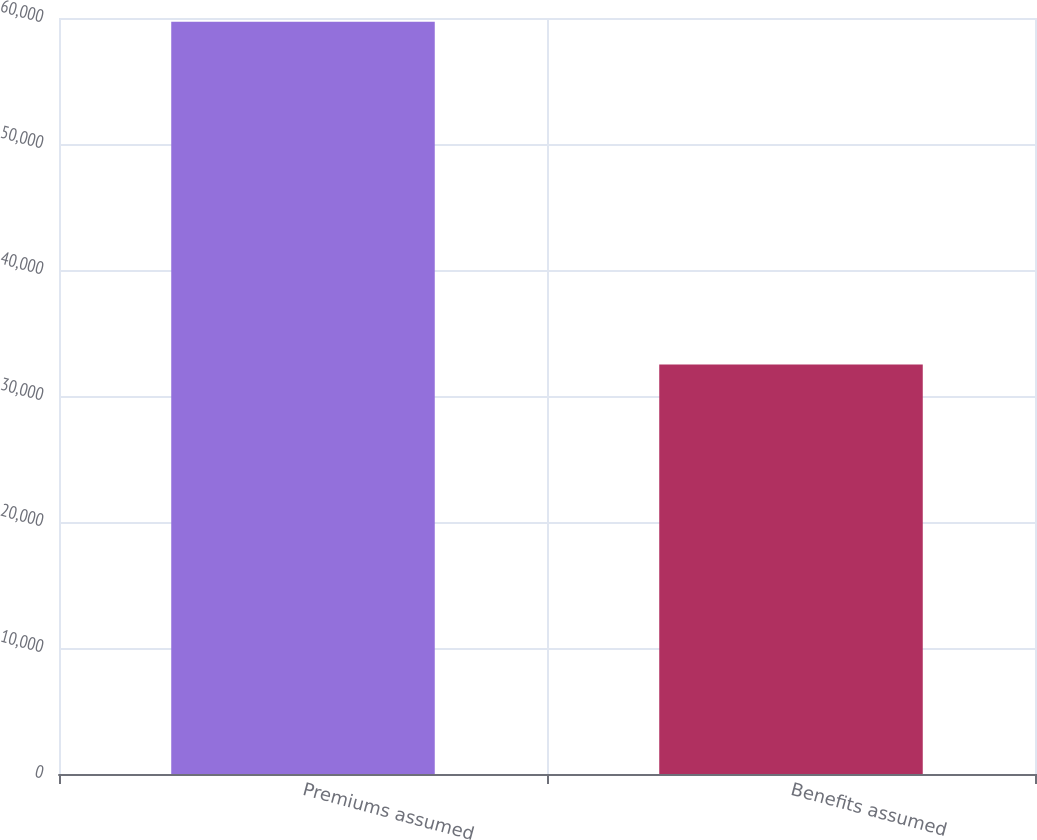Convert chart. <chart><loc_0><loc_0><loc_500><loc_500><bar_chart><fcel>Premiums assumed<fcel>Benefits assumed<nl><fcel>59706<fcel>32494<nl></chart> 